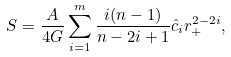<formula> <loc_0><loc_0><loc_500><loc_500>S = \frac { A } { 4 G } \sum _ { i = 1 } ^ { m } \frac { i ( n - 1 ) } { n - 2 i + 1 } \hat { c } _ { i } r _ { + } ^ { 2 - 2 i } ,</formula> 